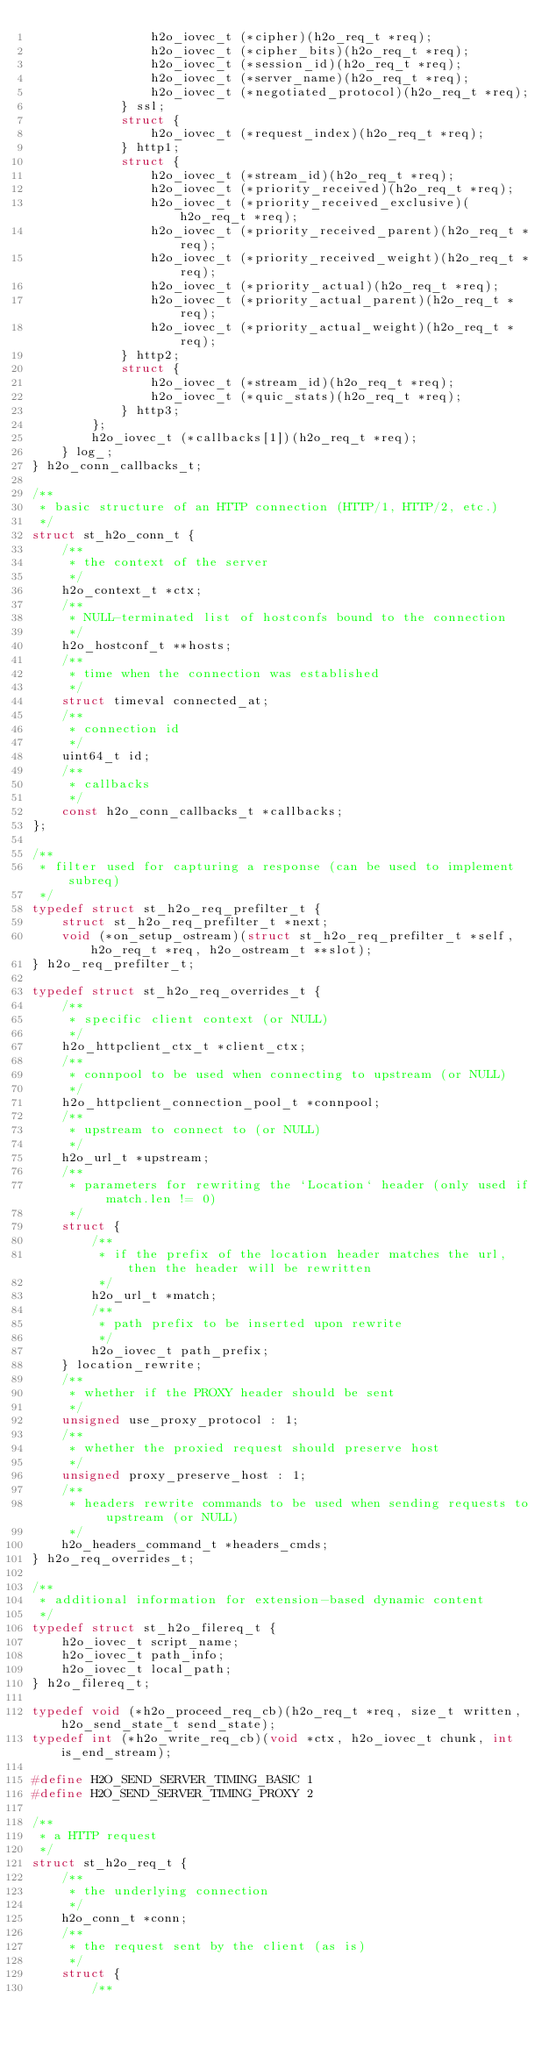Convert code to text. <code><loc_0><loc_0><loc_500><loc_500><_C_>                h2o_iovec_t (*cipher)(h2o_req_t *req);
                h2o_iovec_t (*cipher_bits)(h2o_req_t *req);
                h2o_iovec_t (*session_id)(h2o_req_t *req);
                h2o_iovec_t (*server_name)(h2o_req_t *req);
                h2o_iovec_t (*negotiated_protocol)(h2o_req_t *req);
            } ssl;
            struct {
                h2o_iovec_t (*request_index)(h2o_req_t *req);
            } http1;
            struct {
                h2o_iovec_t (*stream_id)(h2o_req_t *req);
                h2o_iovec_t (*priority_received)(h2o_req_t *req);
                h2o_iovec_t (*priority_received_exclusive)(h2o_req_t *req);
                h2o_iovec_t (*priority_received_parent)(h2o_req_t *req);
                h2o_iovec_t (*priority_received_weight)(h2o_req_t *req);
                h2o_iovec_t (*priority_actual)(h2o_req_t *req);
                h2o_iovec_t (*priority_actual_parent)(h2o_req_t *req);
                h2o_iovec_t (*priority_actual_weight)(h2o_req_t *req);
            } http2;
            struct {
                h2o_iovec_t (*stream_id)(h2o_req_t *req);
                h2o_iovec_t (*quic_stats)(h2o_req_t *req);
            } http3;
        };
        h2o_iovec_t (*callbacks[1])(h2o_req_t *req);
    } log_;
} h2o_conn_callbacks_t;

/**
 * basic structure of an HTTP connection (HTTP/1, HTTP/2, etc.)
 */
struct st_h2o_conn_t {
    /**
     * the context of the server
     */
    h2o_context_t *ctx;
    /**
     * NULL-terminated list of hostconfs bound to the connection
     */
    h2o_hostconf_t **hosts;
    /**
     * time when the connection was established
     */
    struct timeval connected_at;
    /**
     * connection id
     */
    uint64_t id;
    /**
     * callbacks
     */
    const h2o_conn_callbacks_t *callbacks;
};

/**
 * filter used for capturing a response (can be used to implement subreq)
 */
typedef struct st_h2o_req_prefilter_t {
    struct st_h2o_req_prefilter_t *next;
    void (*on_setup_ostream)(struct st_h2o_req_prefilter_t *self, h2o_req_t *req, h2o_ostream_t **slot);
} h2o_req_prefilter_t;

typedef struct st_h2o_req_overrides_t {
    /**
     * specific client context (or NULL)
     */
    h2o_httpclient_ctx_t *client_ctx;
    /**
     * connpool to be used when connecting to upstream (or NULL)
     */
    h2o_httpclient_connection_pool_t *connpool;
    /**
     * upstream to connect to (or NULL)
     */
    h2o_url_t *upstream;
    /**
     * parameters for rewriting the `Location` header (only used if match.len != 0)
     */
    struct {
        /**
         * if the prefix of the location header matches the url, then the header will be rewritten
         */
        h2o_url_t *match;
        /**
         * path prefix to be inserted upon rewrite
         */
        h2o_iovec_t path_prefix;
    } location_rewrite;
    /**
     * whether if the PROXY header should be sent
     */
    unsigned use_proxy_protocol : 1;
    /**
     * whether the proxied request should preserve host
     */
    unsigned proxy_preserve_host : 1;
    /**
     * headers rewrite commands to be used when sending requests to upstream (or NULL)
     */
    h2o_headers_command_t *headers_cmds;
} h2o_req_overrides_t;

/**
 * additional information for extension-based dynamic content
 */
typedef struct st_h2o_filereq_t {
    h2o_iovec_t script_name;
    h2o_iovec_t path_info;
    h2o_iovec_t local_path;
} h2o_filereq_t;

typedef void (*h2o_proceed_req_cb)(h2o_req_t *req, size_t written, h2o_send_state_t send_state);
typedef int (*h2o_write_req_cb)(void *ctx, h2o_iovec_t chunk, int is_end_stream);

#define H2O_SEND_SERVER_TIMING_BASIC 1
#define H2O_SEND_SERVER_TIMING_PROXY 2

/**
 * a HTTP request
 */
struct st_h2o_req_t {
    /**
     * the underlying connection
     */
    h2o_conn_t *conn;
    /**
     * the request sent by the client (as is)
     */
    struct {
        /**</code> 